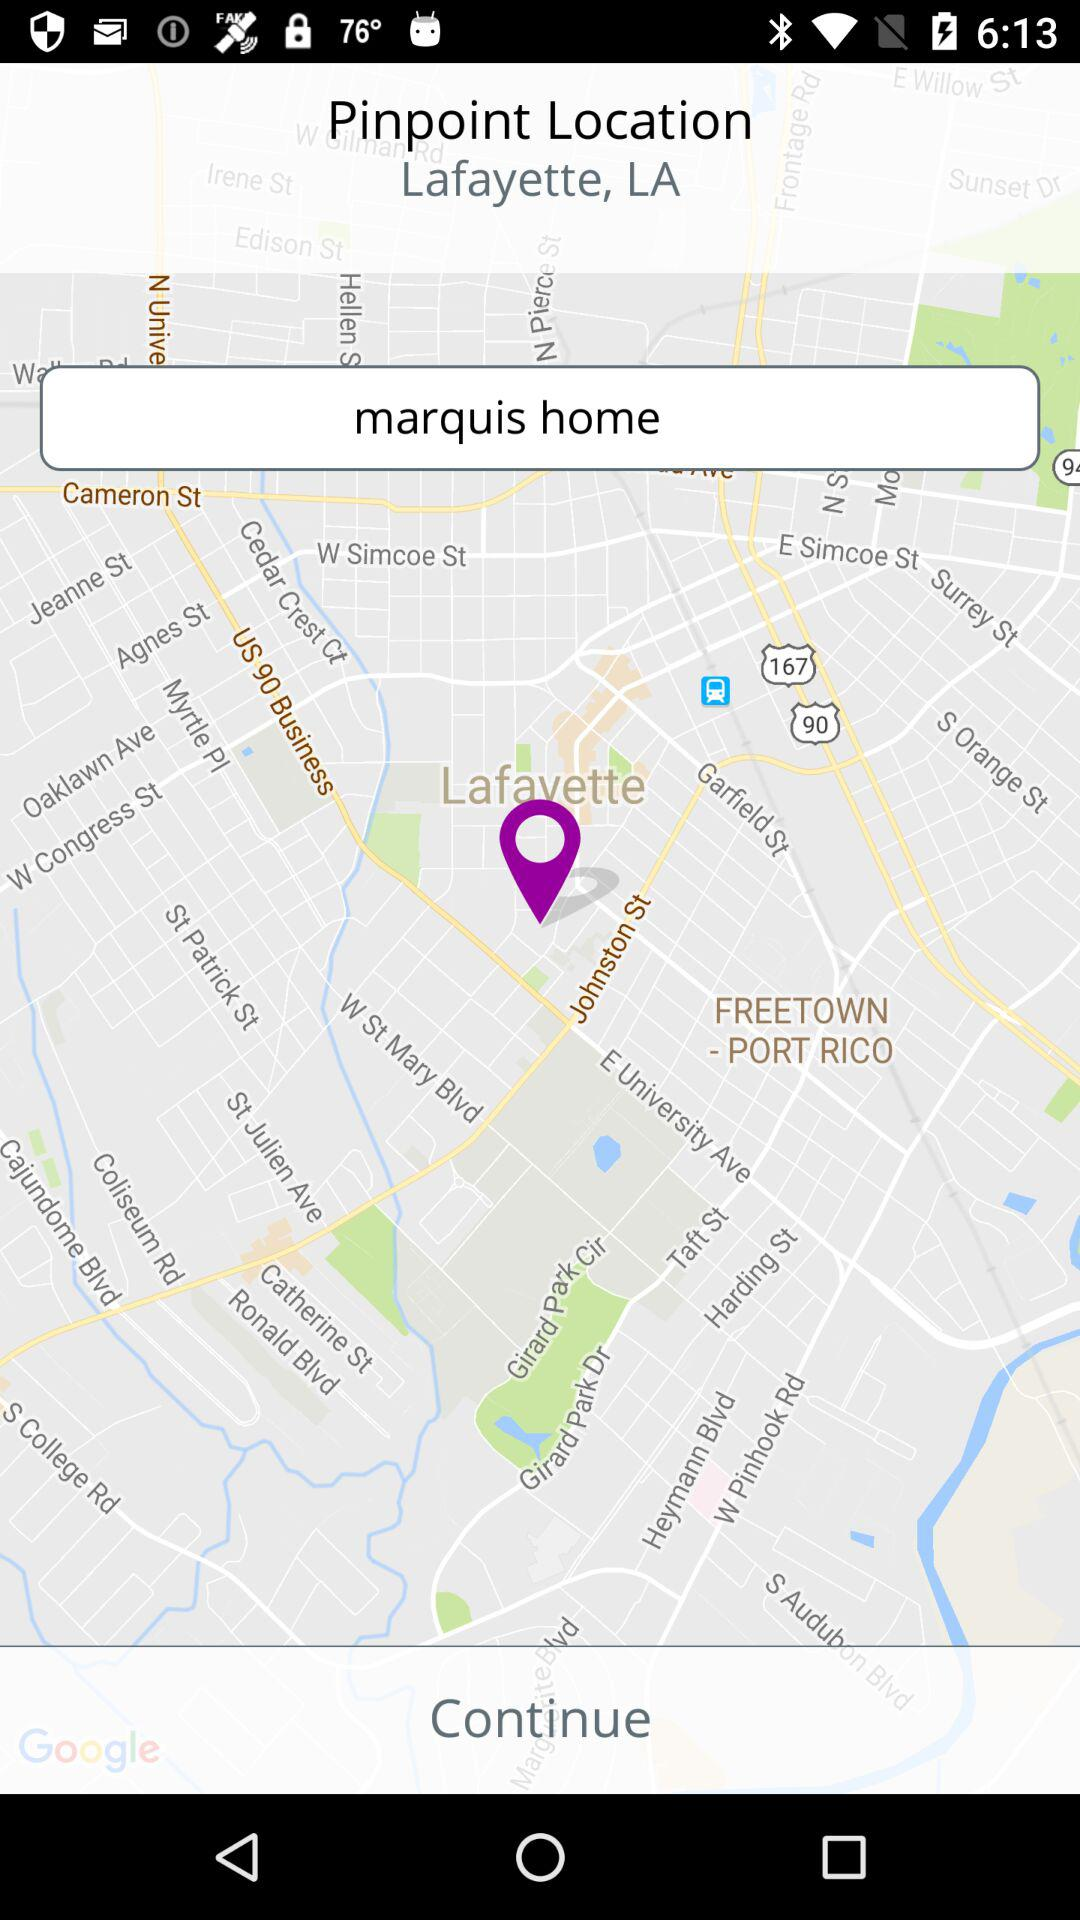Which place is selected on the map? The selected place on the map is Lafayette, LA. 